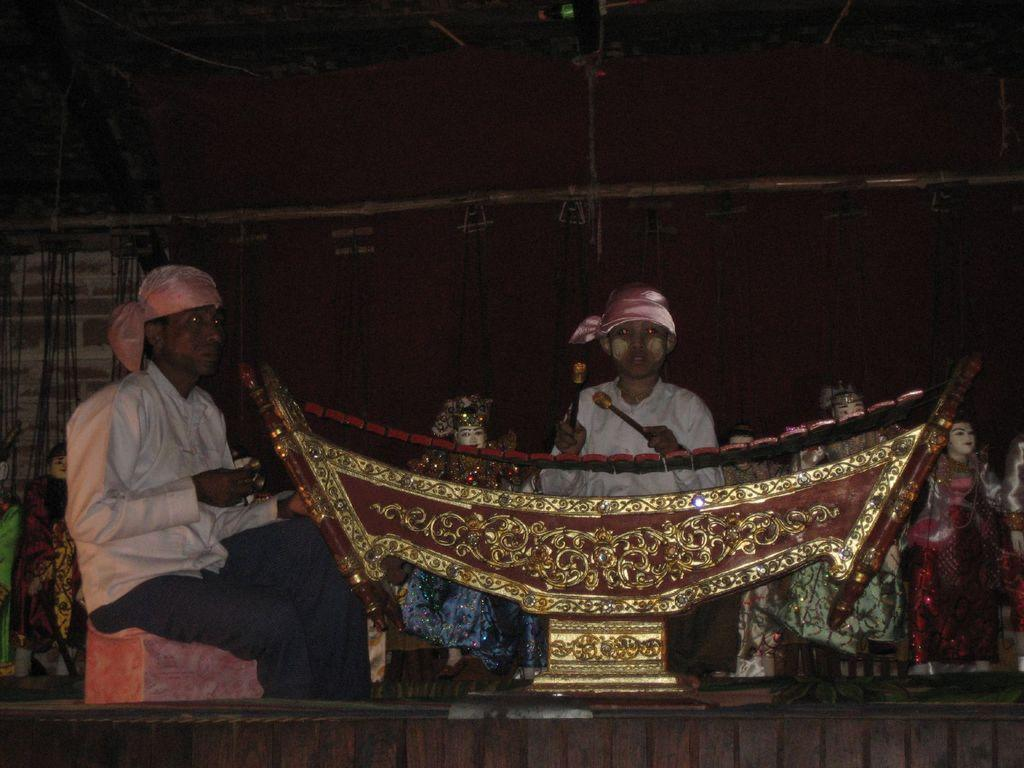What are the people in the image doing? The people in the image are sitting. What are the people holding in their hands? The people are holding something in their hands, but the specific object is not mentioned in the facts. What can be seen in the image besides the people? There are idols in the image. What is visible in the background of the image? There is a wall in the background of the image. How many toes can be seen on the idols in the image? There is no mention of toes or idols having toes in the provided facts, so it cannot be determined from the image. 